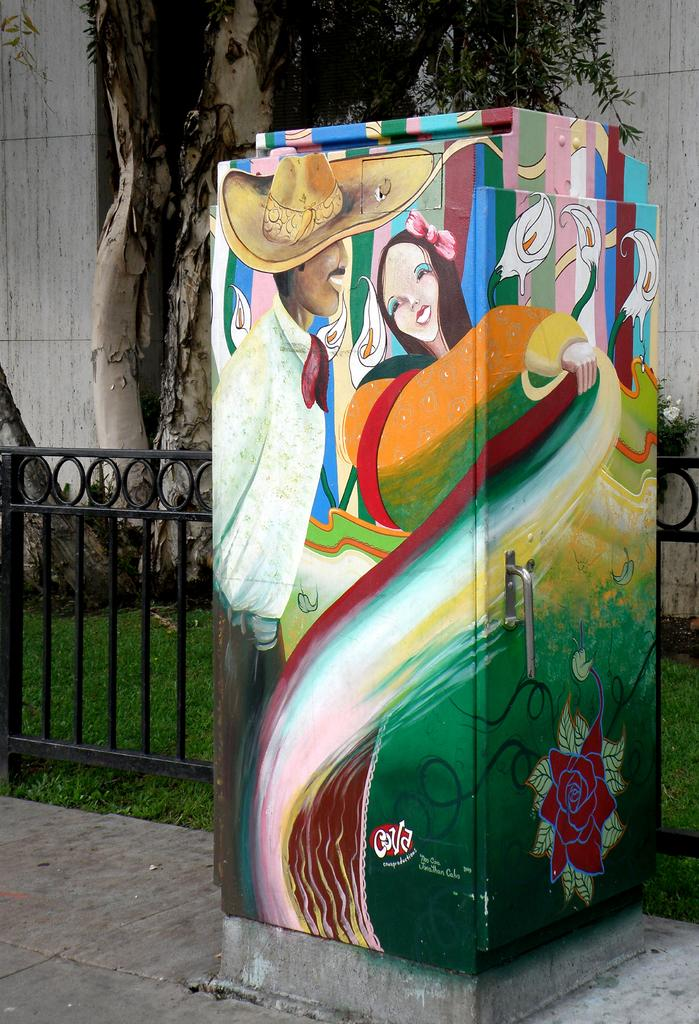What is depicted on the box in the image? There is a painting on a box in the image. What is located beside the box in the image? There is a fence beside the box in the image. What can be seen in the background of the image? There is a tree and grass visible in the background of the image. How many flies are sitting on the painting in the image? There are no flies present in the image. What company is responsible for the fence in the image? The image does not provide information about the company responsible for the fence. 